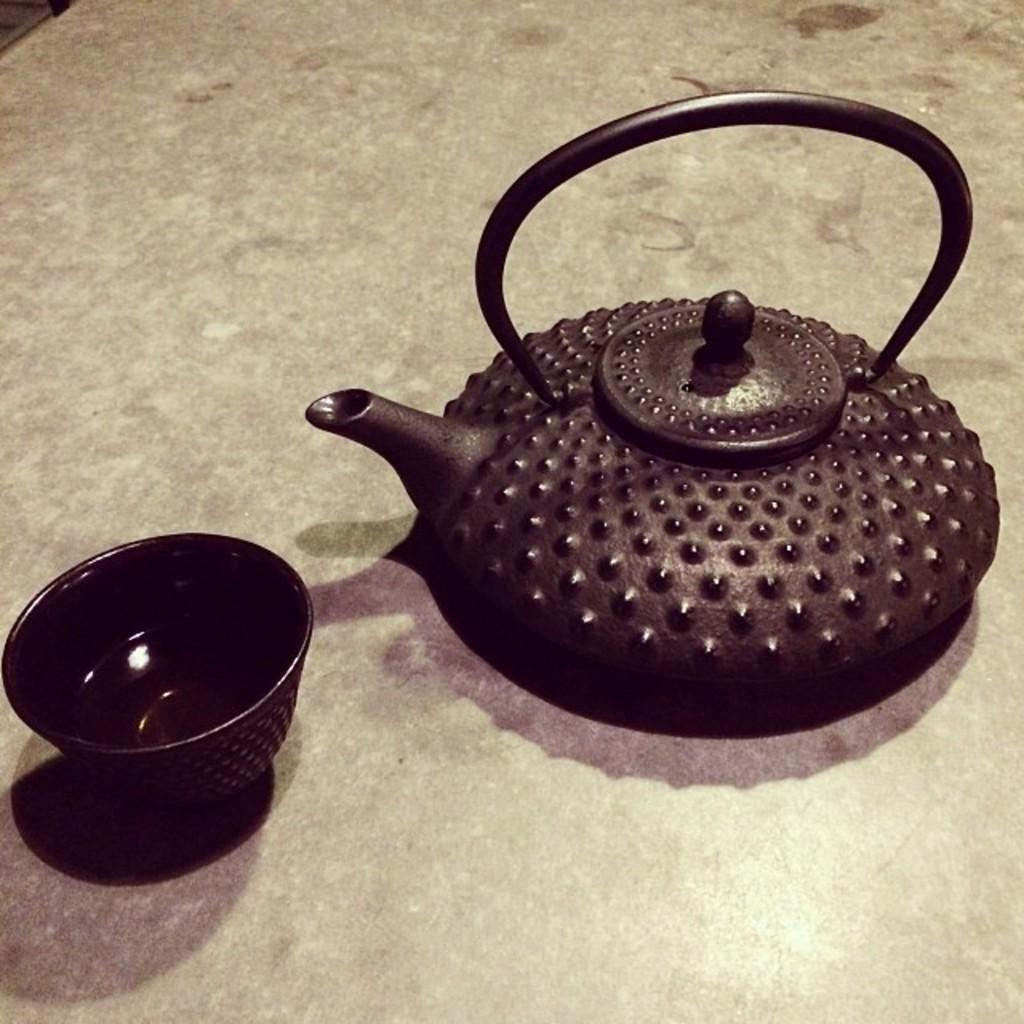What is the main object in the image? There is a teapot in the image. What other object is present in the image? There is a bowl in the image. Where are the teapot and bowl located? The teapot and bowl are placed on a surface. What type of insurance is being discussed in the image? There is no discussion of insurance in the image; it features a teapot and a bowl placed on a surface. 